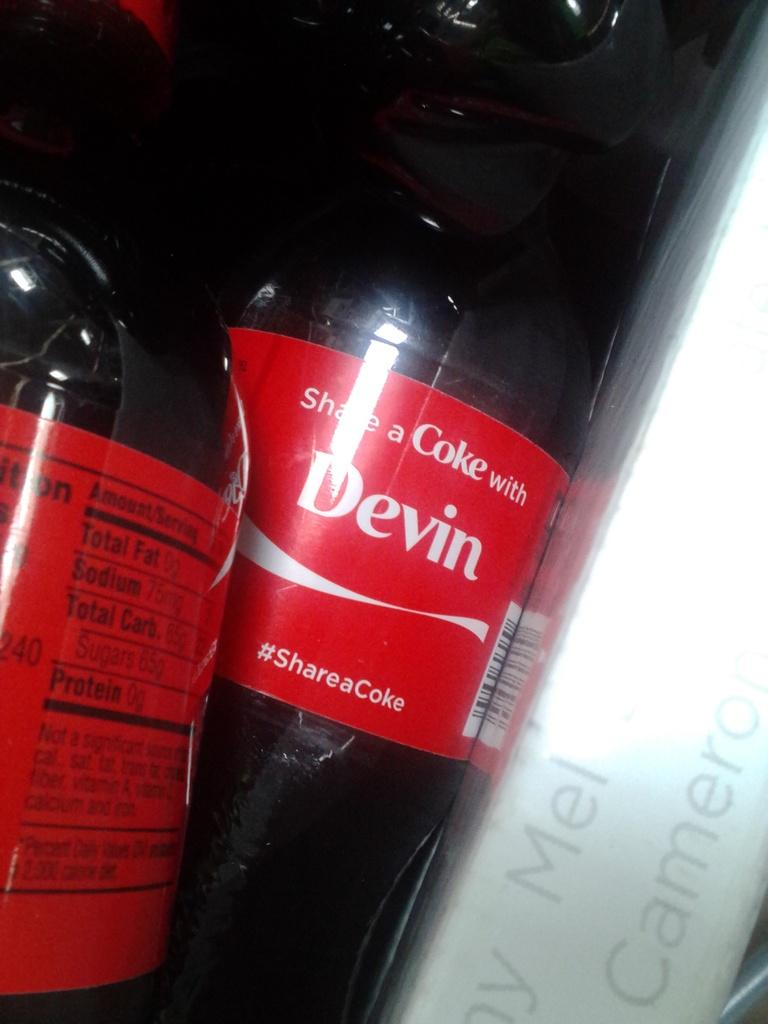<image>
Describe the image concisely. the word devin is on the coca cola bottle 